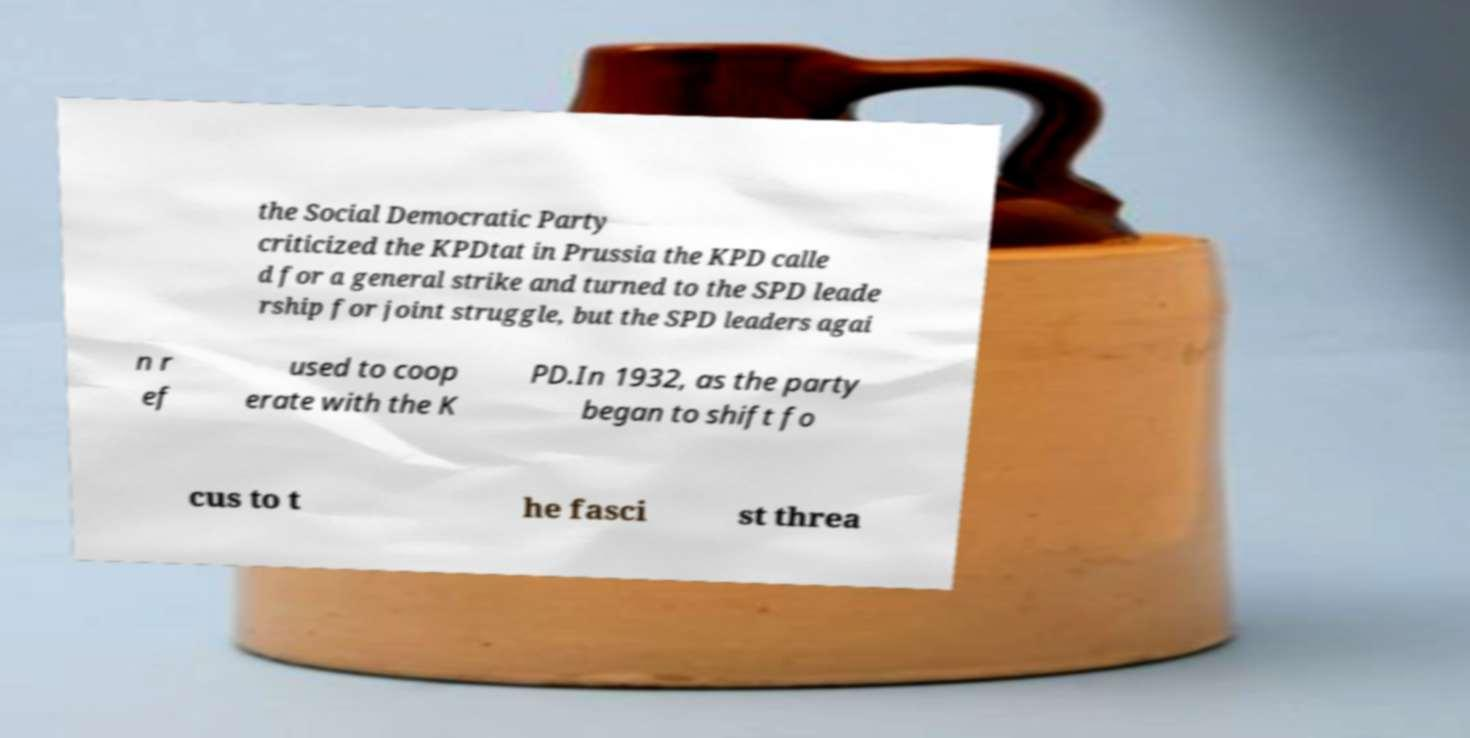There's text embedded in this image that I need extracted. Can you transcribe it verbatim? the Social Democratic Party criticized the KPDtat in Prussia the KPD calle d for a general strike and turned to the SPD leade rship for joint struggle, but the SPD leaders agai n r ef used to coop erate with the K PD.In 1932, as the party began to shift fo cus to t he fasci st threa 